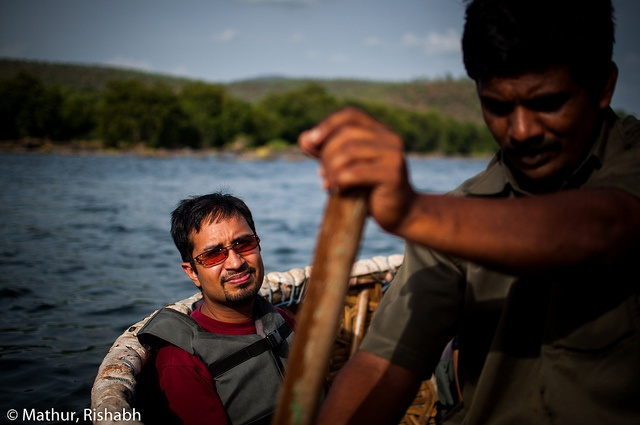Describe the objects in this image and their specific colors. I can see people in black, maroon, and brown tones, people in black, maroon, gray, and brown tones, and boat in black, maroon, and gray tones in this image. 